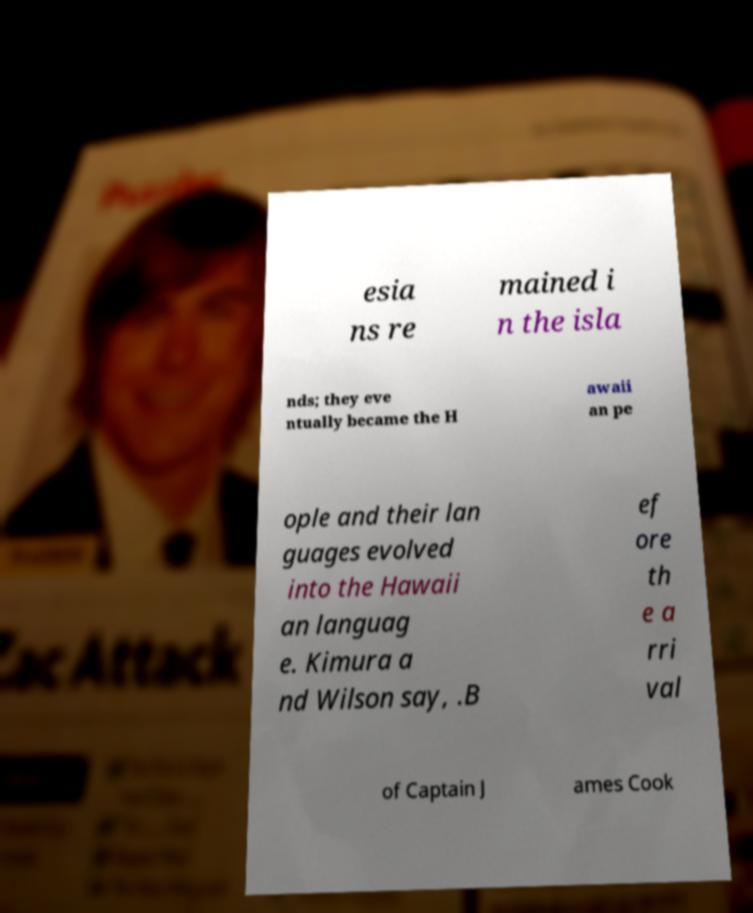Could you assist in decoding the text presented in this image and type it out clearly? esia ns re mained i n the isla nds; they eve ntually became the H awaii an pe ople and their lan guages evolved into the Hawaii an languag e. Kimura a nd Wilson say, .B ef ore th e a rri val of Captain J ames Cook 